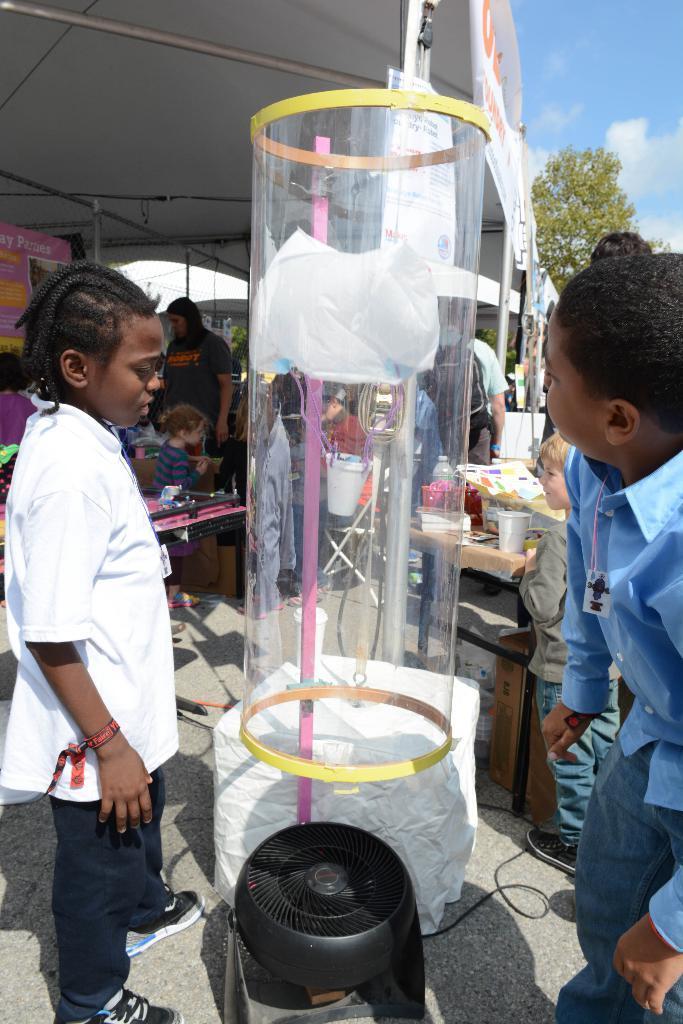Could you give a brief overview of what you see in this image? In this image I can see a boy wearing white and black colored dress and another boy wearing blue colored dress are standing around an object which is black, white and transparent. In the background I can see few persons standing, a tent, a tree, the sky and few other objects. 